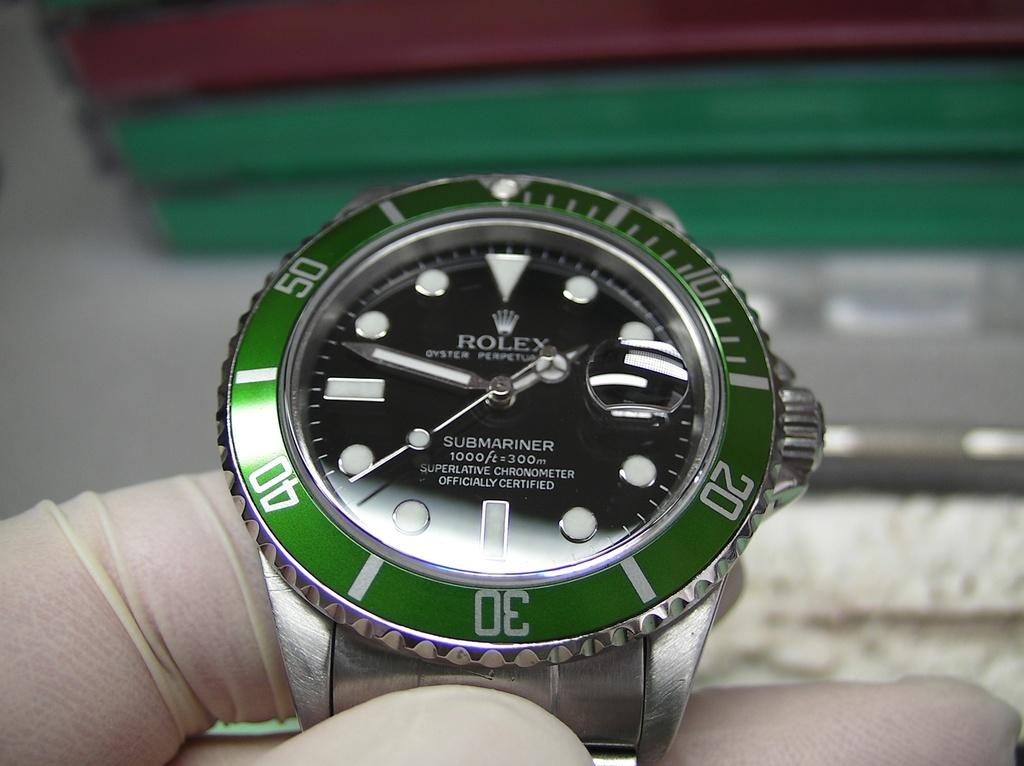Provide a one-sentence caption for the provided image. someone with gloves is holding a green Rolex watch that reads 1:48. 